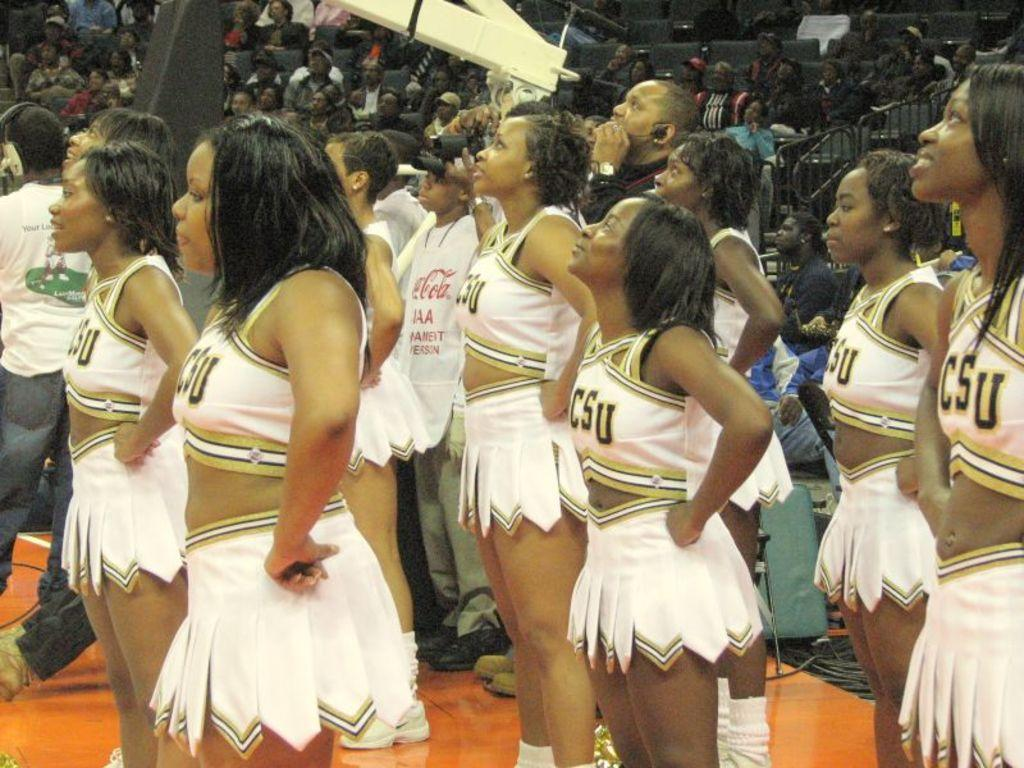<image>
Describe the image concisely. a group of cheerleaders with csu shirts on their back 